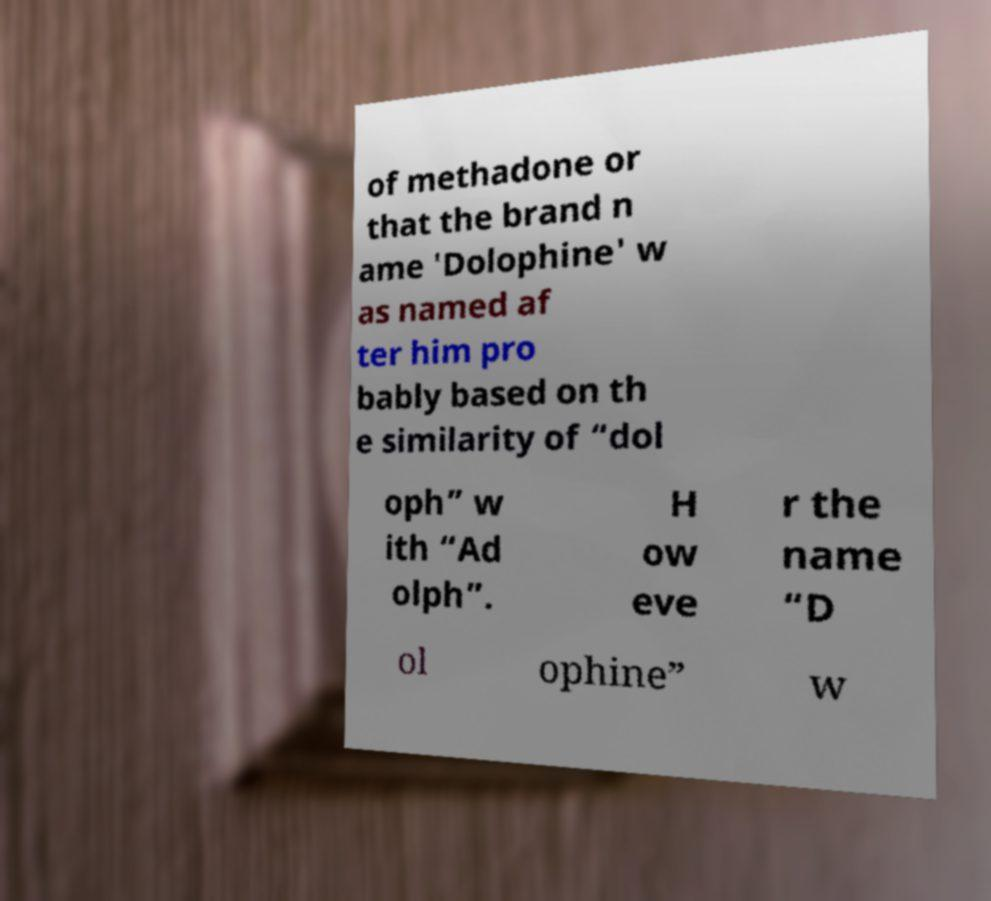Could you extract and type out the text from this image? of methadone or that the brand n ame 'Dolophine' w as named af ter him pro bably based on th e similarity of “dol oph” w ith “Ad olph”. H ow eve r the name “D ol ophine” w 